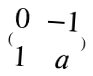Convert formula to latex. <formula><loc_0><loc_0><loc_500><loc_500>( \begin{matrix} 0 & - 1 \\ 1 & a \\ \end{matrix} )</formula> 